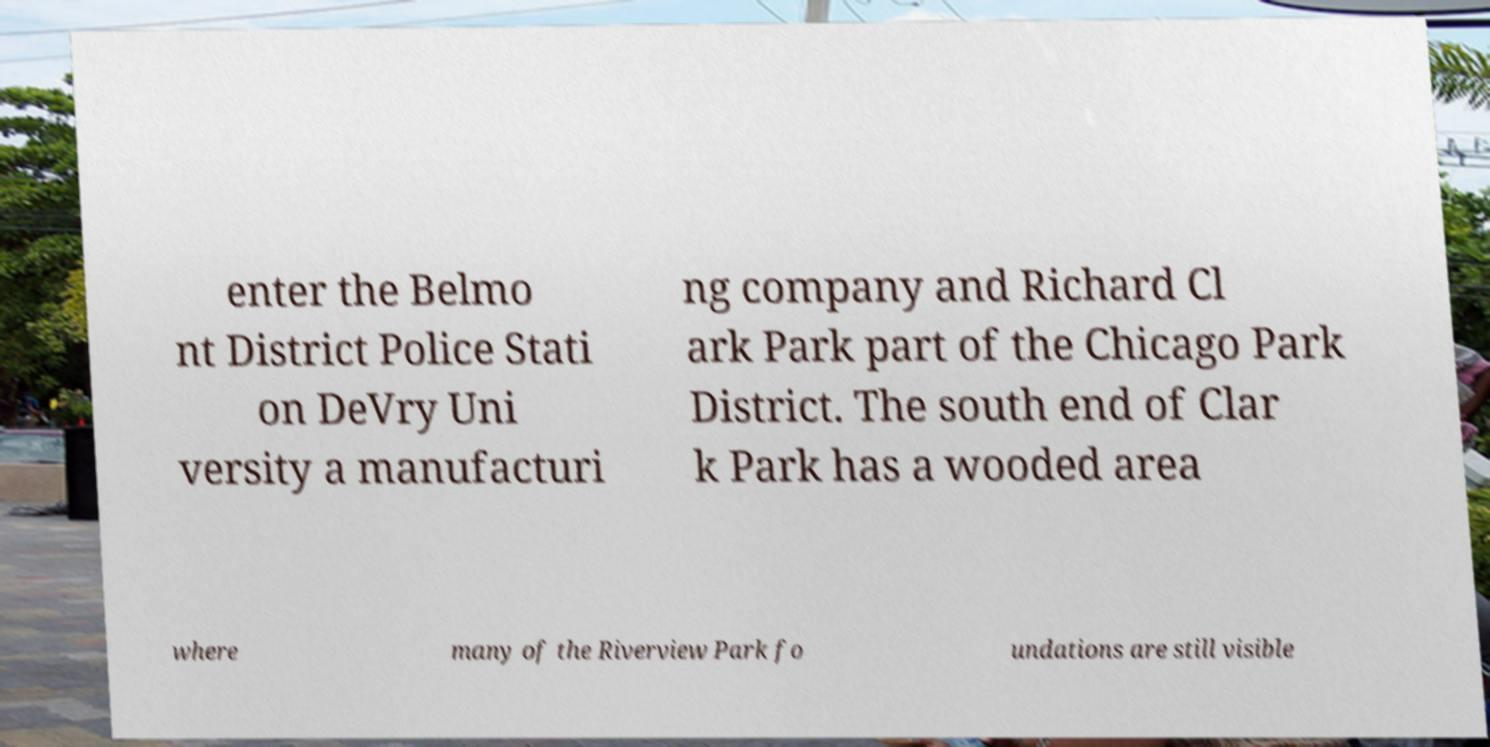Could you extract and type out the text from this image? enter the Belmo nt District Police Stati on DeVry Uni versity a manufacturi ng company and Richard Cl ark Park part of the Chicago Park District. The south end of Clar k Park has a wooded area where many of the Riverview Park fo undations are still visible 